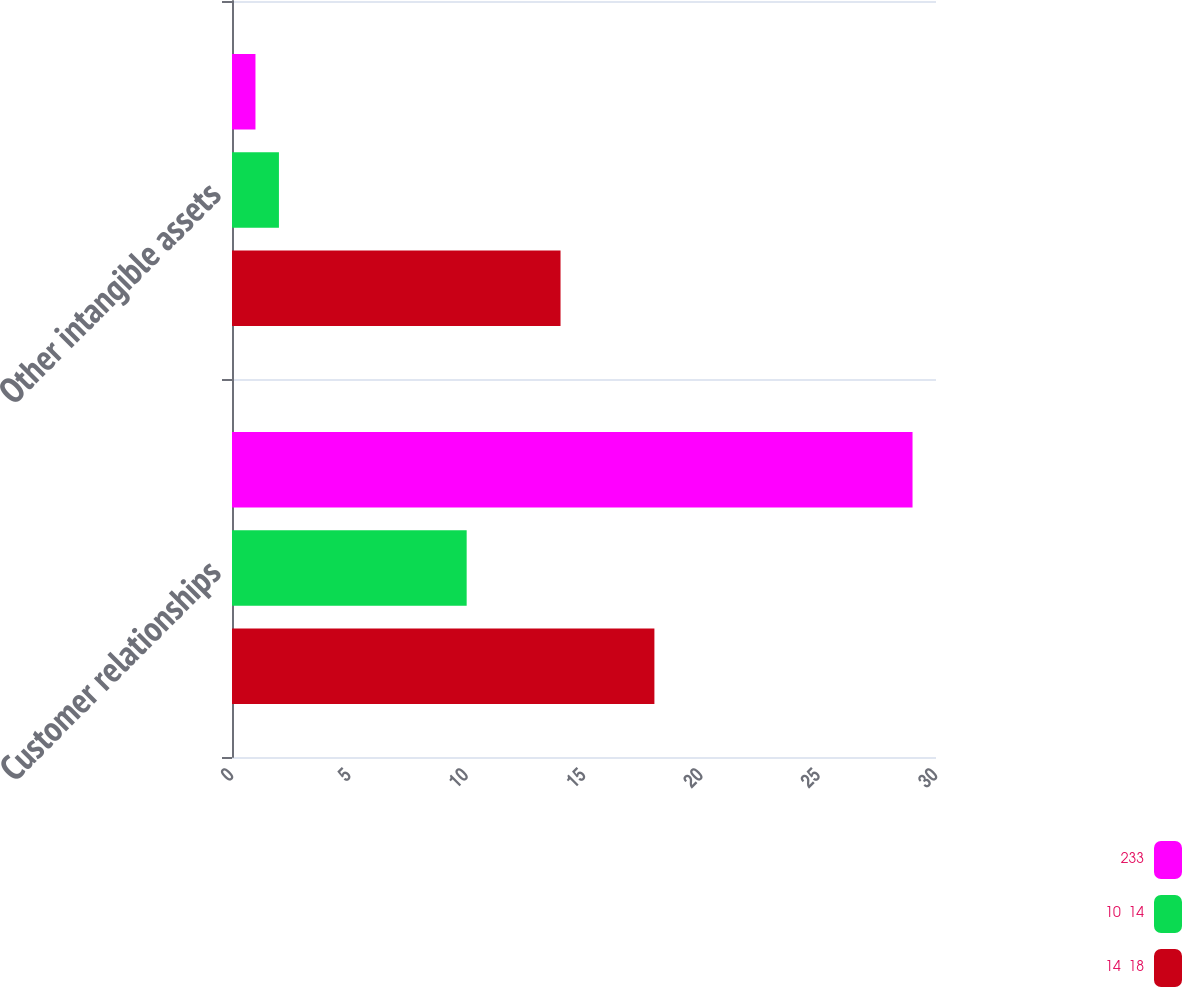Convert chart. <chart><loc_0><loc_0><loc_500><loc_500><stacked_bar_chart><ecel><fcel>Customer relationships<fcel>Other intangible assets<nl><fcel>233<fcel>29<fcel>1<nl><fcel>10  14<fcel>10<fcel>2<nl><fcel>14  18<fcel>18<fcel>14<nl></chart> 